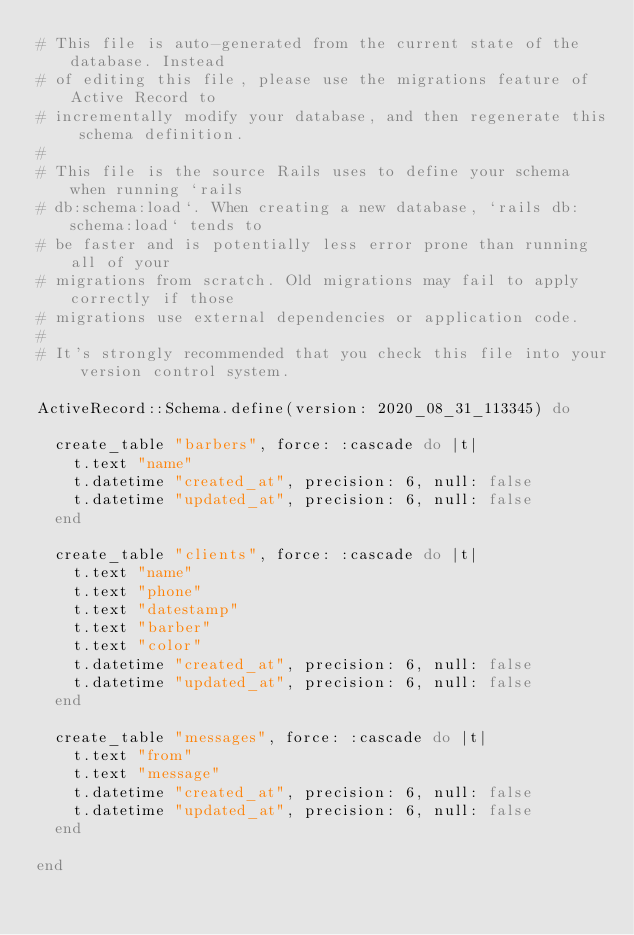Convert code to text. <code><loc_0><loc_0><loc_500><loc_500><_Ruby_># This file is auto-generated from the current state of the database. Instead
# of editing this file, please use the migrations feature of Active Record to
# incrementally modify your database, and then regenerate this schema definition.
#
# This file is the source Rails uses to define your schema when running `rails
# db:schema:load`. When creating a new database, `rails db:schema:load` tends to
# be faster and is potentially less error prone than running all of your
# migrations from scratch. Old migrations may fail to apply correctly if those
# migrations use external dependencies or application code.
#
# It's strongly recommended that you check this file into your version control system.

ActiveRecord::Schema.define(version: 2020_08_31_113345) do

  create_table "barbers", force: :cascade do |t|
    t.text "name"
    t.datetime "created_at", precision: 6, null: false
    t.datetime "updated_at", precision: 6, null: false
  end

  create_table "clients", force: :cascade do |t|
    t.text "name"
    t.text "phone"
    t.text "datestamp"
    t.text "barber"
    t.text "color"
    t.datetime "created_at", precision: 6, null: false
    t.datetime "updated_at", precision: 6, null: false
  end

  create_table "messages", force: :cascade do |t|
    t.text "from"
    t.text "message"
    t.datetime "created_at", precision: 6, null: false
    t.datetime "updated_at", precision: 6, null: false
  end

end
</code> 